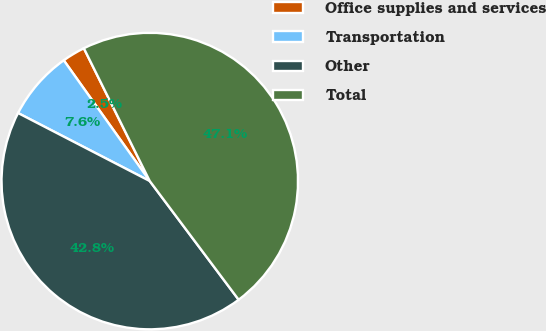Convert chart to OTSL. <chart><loc_0><loc_0><loc_500><loc_500><pie_chart><fcel>Office supplies and services<fcel>Transportation<fcel>Other<fcel>Total<nl><fcel>2.52%<fcel>7.56%<fcel>42.82%<fcel>47.1%<nl></chart> 